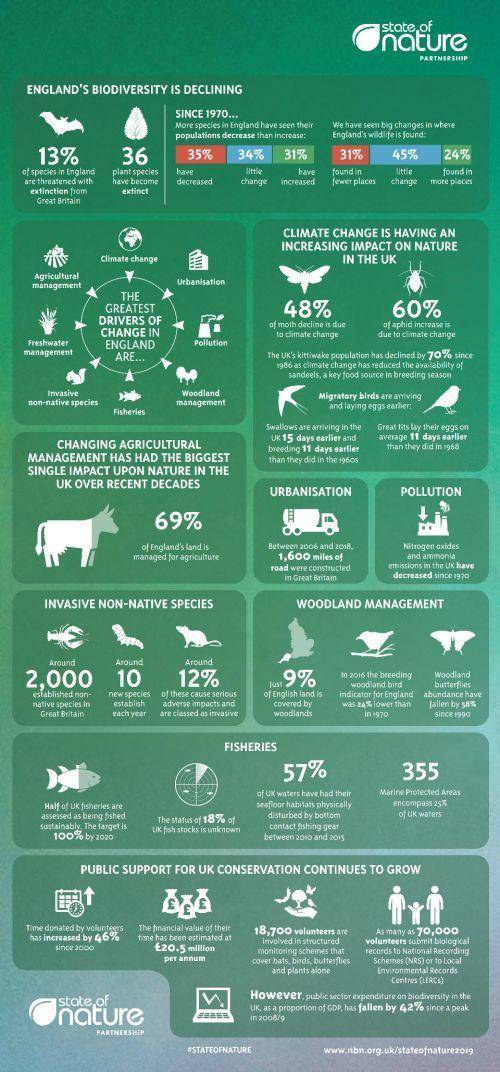what percentage of fishing is done sustainably
Answer the question with a short phrase. 50 Which gas emissions have reduced since 1970 nitrogen oxides and ammonia what % of species have se little change in their population since 1970 34% what encompass 25% of UK waters 355 marine protected areas how many plant species have become extinct 36 what has disturbed the seafloor habitats bottom contact fishing gear how much land is managed for agriculture 69% 